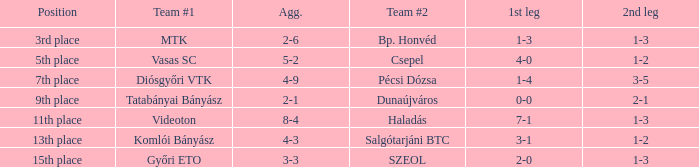What is the opening leg with a 4-3 combined score? 3-1. 